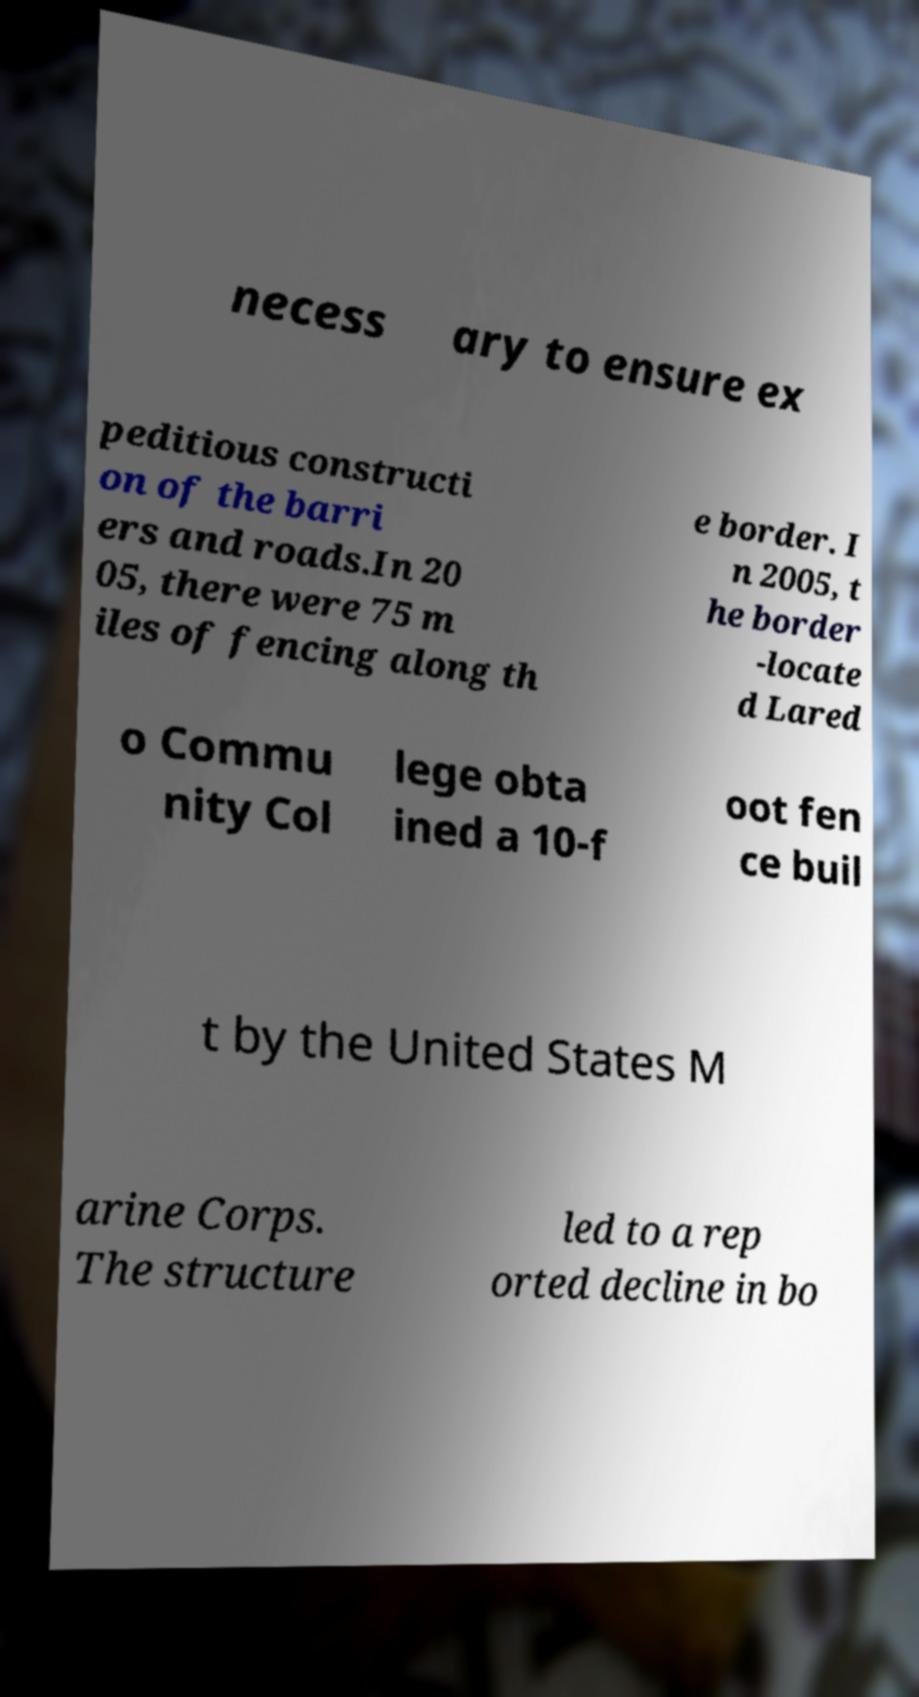Can you accurately transcribe the text from the provided image for me? necess ary to ensure ex peditious constructi on of the barri ers and roads.In 20 05, there were 75 m iles of fencing along th e border. I n 2005, t he border -locate d Lared o Commu nity Col lege obta ined a 10-f oot fen ce buil t by the United States M arine Corps. The structure led to a rep orted decline in bo 